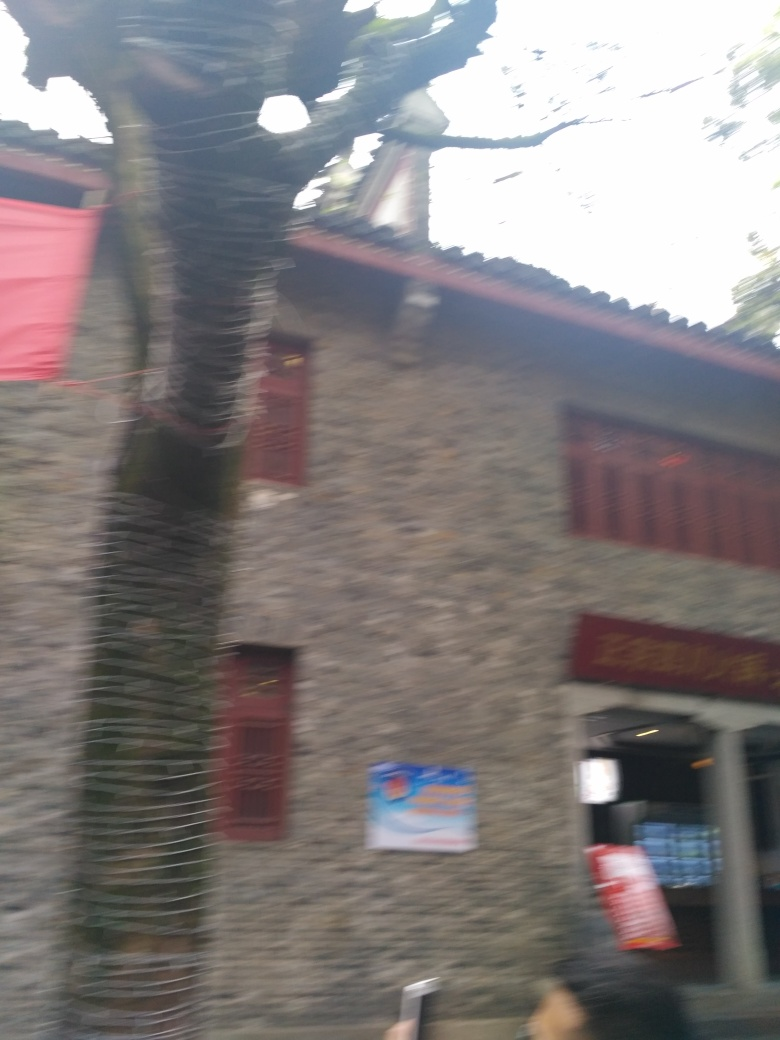Are there any quality issues with this image? Yes, the image suffers from significant motion blur, poor focus, and overexposure in some areas, resulting in a lack of sharpness and detail that would enhance the clarity of the subject matter. 